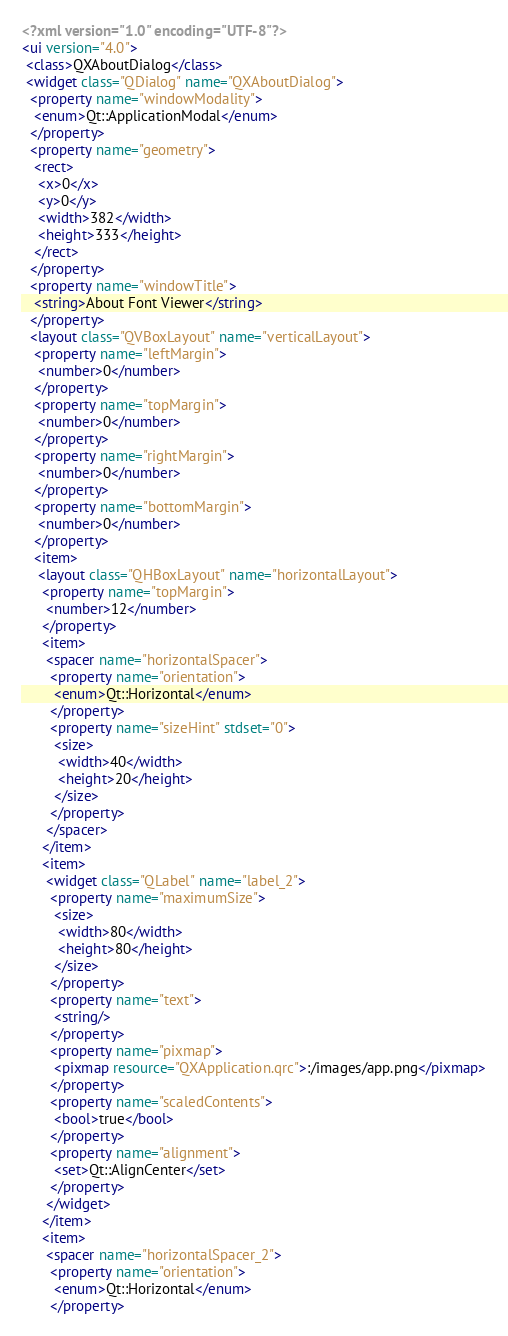Convert code to text. <code><loc_0><loc_0><loc_500><loc_500><_XML_><?xml version="1.0" encoding="UTF-8"?>
<ui version="4.0">
 <class>QXAboutDialog</class>
 <widget class="QDialog" name="QXAboutDialog">
  <property name="windowModality">
   <enum>Qt::ApplicationModal</enum>
  </property>
  <property name="geometry">
   <rect>
    <x>0</x>
    <y>0</y>
    <width>382</width>
    <height>333</height>
   </rect>
  </property>
  <property name="windowTitle">
   <string>About Font Viewer</string>
  </property>
  <layout class="QVBoxLayout" name="verticalLayout">
   <property name="leftMargin">
    <number>0</number>
   </property>
   <property name="topMargin">
    <number>0</number>
   </property>
   <property name="rightMargin">
    <number>0</number>
   </property>
   <property name="bottomMargin">
    <number>0</number>
   </property>
   <item>
    <layout class="QHBoxLayout" name="horizontalLayout">
     <property name="topMargin">
      <number>12</number>
     </property>
     <item>
      <spacer name="horizontalSpacer">
       <property name="orientation">
        <enum>Qt::Horizontal</enum>
       </property>
       <property name="sizeHint" stdset="0">
        <size>
         <width>40</width>
         <height>20</height>
        </size>
       </property>
      </spacer>
     </item>
     <item>
      <widget class="QLabel" name="label_2">
       <property name="maximumSize">
        <size>
         <width>80</width>
         <height>80</height>
        </size>
       </property>
       <property name="text">
        <string/>
       </property>
       <property name="pixmap">
        <pixmap resource="QXApplication.qrc">:/images/app.png</pixmap>
       </property>
       <property name="scaledContents">
        <bool>true</bool>
       </property>
       <property name="alignment">
        <set>Qt::AlignCenter</set>
       </property>
      </widget>
     </item>
     <item>
      <spacer name="horizontalSpacer_2">
       <property name="orientation">
        <enum>Qt::Horizontal</enum>
       </property></code> 